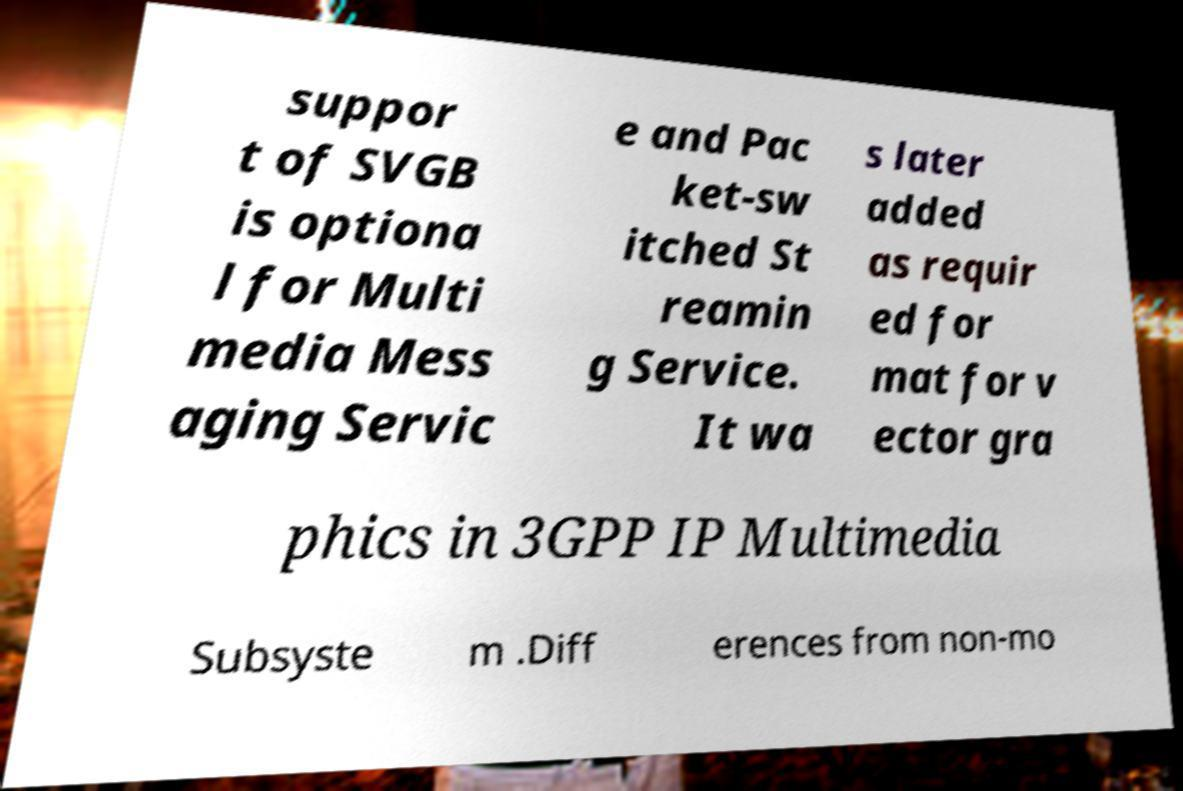Can you accurately transcribe the text from the provided image for me? suppor t of SVGB is optiona l for Multi media Mess aging Servic e and Pac ket-sw itched St reamin g Service. It wa s later added as requir ed for mat for v ector gra phics in 3GPP IP Multimedia Subsyste m .Diff erences from non-mo 